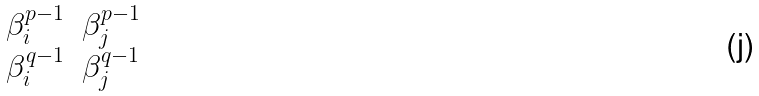<formula> <loc_0><loc_0><loc_500><loc_500>\begin{matrix} \beta _ { i } ^ { p - 1 } & \beta _ { j } ^ { p - 1 } \\ \beta _ { i } ^ { q - 1 } & \beta _ { j } ^ { q - 1 } \end{matrix}</formula> 